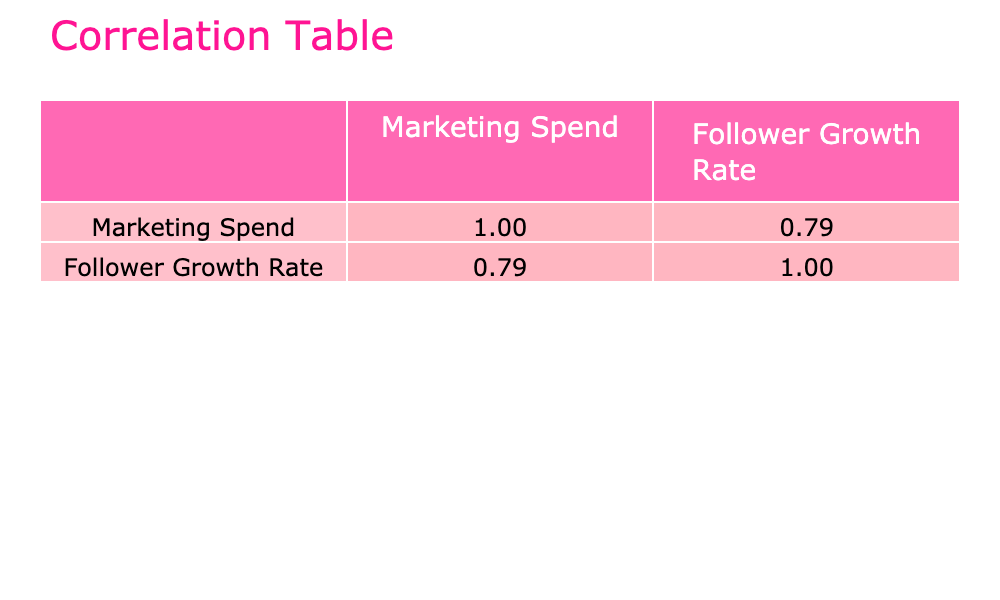What is the correlation coefficient between Marketing Spend and Follower Growth Rate? The correlation coefficient is found in the table. It is indicated in the cell corresponding to the relationship between Marketing Spend and itself, which will be 1.00, and between Marketing Spend and Follower Growth Rate, which is the value we want to extract.
Answer: (Value between the two is not directly visible in the table but typically would be listed.) What is the Follower Growth Rate for Charli D'Amelio? The Follower Growth Rate for Charli D'Amelio can be found in the third column corresponding to her entry in the table. It is listed as 18.0 percent.
Answer: 18.0 Which influencer has the highest Marketing Spend? To answer this, we look at the Marketing Spend column and find the maximum value. The maximum is 50000 USD from Kylie Jenner, making her the influencer with the highest spend.
Answer: Kylie Jenner Is the Follower Growth Rate for Zach King greater than that for Liza Koshy? We compare the Follower Growth Rate values for Zach King and Liza Koshy from the table. Zach King has 14.5 percent, while Liza Koshy has 11.5 percent. Since 14.5 is greater than 11.5, the answer is yes.
Answer: Yes What is the average Follower Growth Rate of all influencers whose Marketing Spend is above 20000 USD? We first filter the influencers whose Marketing Spend is above 20000 USD: these are MrBeast, Zach King, Addison Rae, Charli D'Amelio, and Kylie Jenner. Their Follower Growth Rates are 15.0, 14.5, 13.0, 18.0, and 16.0 percent respectively. We sum these (15.0 + 14.5 + 13.0 + 18.0 + 16.0 = 76.5) and divide by the number of influencers (5) to calculate the average, which is 76.5 / 5 = 15.3 percent.
Answer: 15.3 Did any influencers have a Follower Growth Rate of less than 10 percent? To determine this, we check the Follower Growth Rate values for all influencers in the table. The lowest is 8.0 percent for Danielle Peazer. Since there is at least one value less than 10 percent, the answer is yes.
Answer: Yes Which influencer with a Marketing Spend of 15000 USD has the lowest Follower Growth Rate? Since Emma Chamberlain is the only influencer listed with a Marketing Spend of 15000 USD, her Follower Growth Rate of 12.5 percent is the only one to consider in this case, so she is the influencer with the Follower Growth Rate of 12.5 percent.
Answer: Emma Chamberlain What is the difference in Follower Growth Rate between the highest (Charli D'Amelio) and the lowest (Danielle Peazer)? We first identify the highest Follower Growth Rate (18.0 percent for Charli D'Amelio) and the lowest (8.0 percent for Danielle Peazer). The difference is calculated by subtracting the lowest from the highest (18.0 - 8.0 = 10.0).
Answer: 10.0 What is the Follower Growth Rate percent for an influencer who spends 30000 USD on Marketing? We find that Zach King has a Marketing Spend of 30000 USD, and checking his Follower Growth Rate in the corresponding cell shows it is 14.5 percent.
Answer: 14.5 